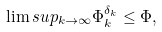<formula> <loc_0><loc_0><loc_500><loc_500>\lim s u p _ { k \to \infty } \Phi ^ { \delta _ { k } } _ { k } \leq \Phi ,</formula> 